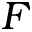<formula> <loc_0><loc_0><loc_500><loc_500>F</formula> 